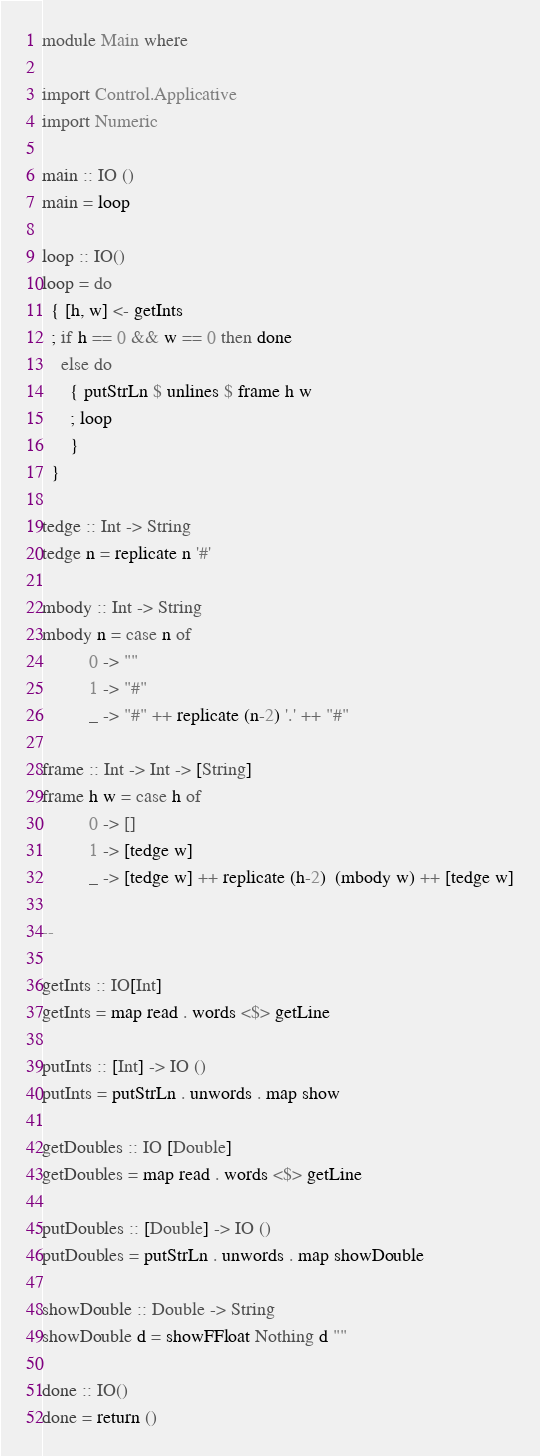Convert code to text. <code><loc_0><loc_0><loc_500><loc_500><_Haskell_>module Main where

import Control.Applicative
import Numeric

main :: IO ()
main = loop

loop :: IO()
loop = do
  { [h, w] <- getInts
  ; if h == 0 && w == 0 then done
    else do
      { putStrLn $ unlines $ frame h w
      ; loop
      }
  }

tedge :: Int -> String
tedge n = replicate n '#'

mbody :: Int -> String
mbody n = case n of
          0 -> ""
          1 -> "#"
          _ -> "#" ++ replicate (n-2) '.' ++ "#"

frame :: Int -> Int -> [String]
frame h w = case h of
          0 -> []
          1 -> [tedge w]
          _ -> [tedge w] ++ replicate (h-2)  (mbody w) ++ [tedge w]

--

getInts :: IO[Int]
getInts = map read . words <$> getLine

putInts :: [Int] -> IO ()
putInts = putStrLn . unwords . map show

getDoubles :: IO [Double]
getDoubles = map read . words <$> getLine

putDoubles :: [Double] -> IO ()
putDoubles = putStrLn . unwords . map showDouble

showDouble :: Double -> String
showDouble d = showFFloat Nothing d ""

done :: IO()
done = return ()

</code> 